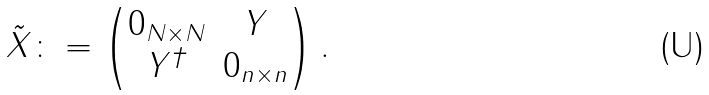<formula> <loc_0><loc_0><loc_500><loc_500>\tilde { X } \colon = \begin{pmatrix} 0 _ { N \times N } & Y \\ Y ^ { \dagger } & 0 _ { n \times n } \end{pmatrix} .</formula> 